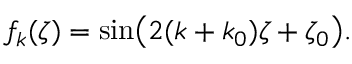Convert formula to latex. <formula><loc_0><loc_0><loc_500><loc_500>f _ { k } ( \zeta ) = \sin \left ( 2 ( k + k _ { 0 } ) \zeta + \zeta _ { 0 } \right ) .</formula> 